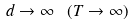<formula> <loc_0><loc_0><loc_500><loc_500>d \to \infty \ ( T \to \infty )</formula> 